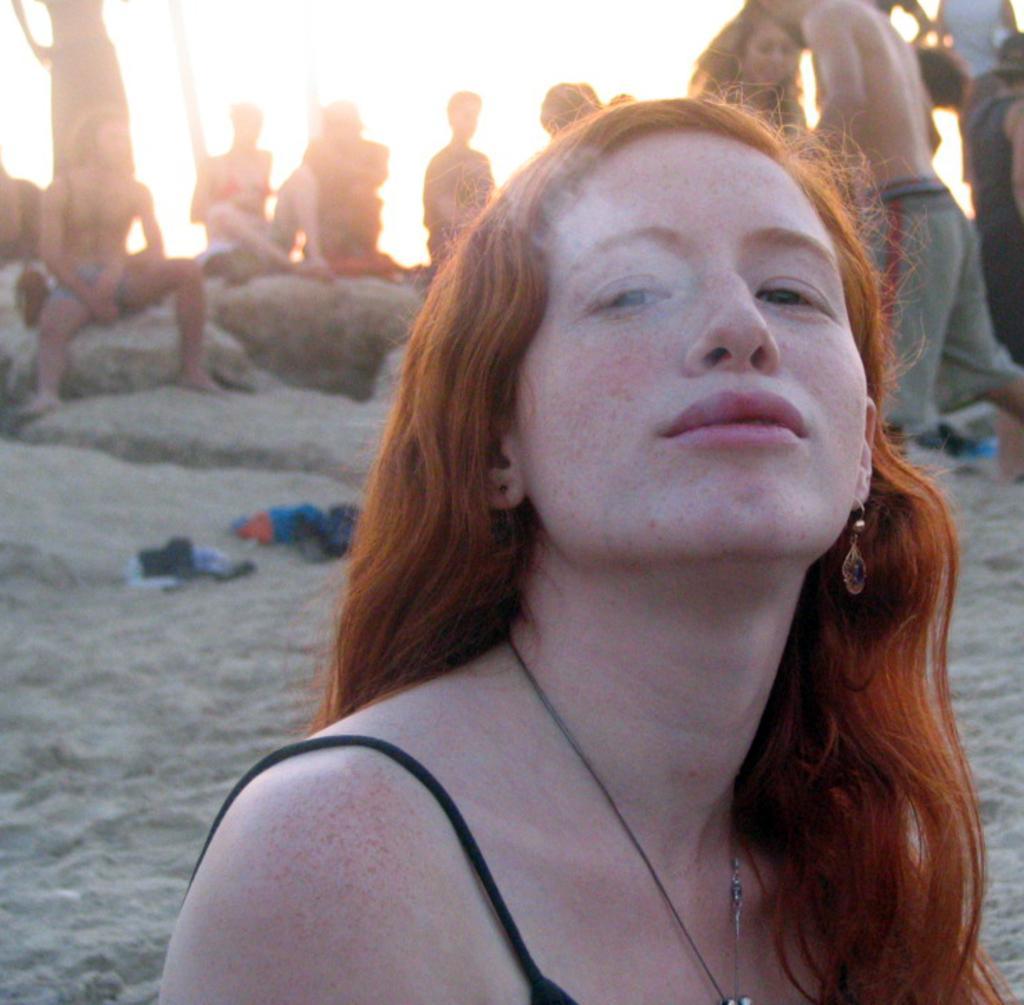In one or two sentences, can you explain what this image depicts? In this image I can see the person wearing the black color dress. To the back of this person I can see few people sitting on the rock. And I can see some clothes on the sand. In the background there is a sky. 